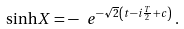<formula> <loc_0><loc_0><loc_500><loc_500>\sinh X = - \ e ^ { - \sqrt { 2 } \left ( t - i \frac { T } { 2 } + c \right ) } \, .</formula> 